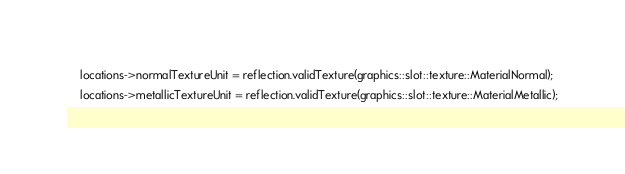Convert code to text. <code><loc_0><loc_0><loc_500><loc_500><_C++_>    locations->normalTextureUnit = reflection.validTexture(graphics::slot::texture::MaterialNormal);
    locations->metallicTextureUnit = reflection.validTexture(graphics::slot::texture::MaterialMetallic);</code> 